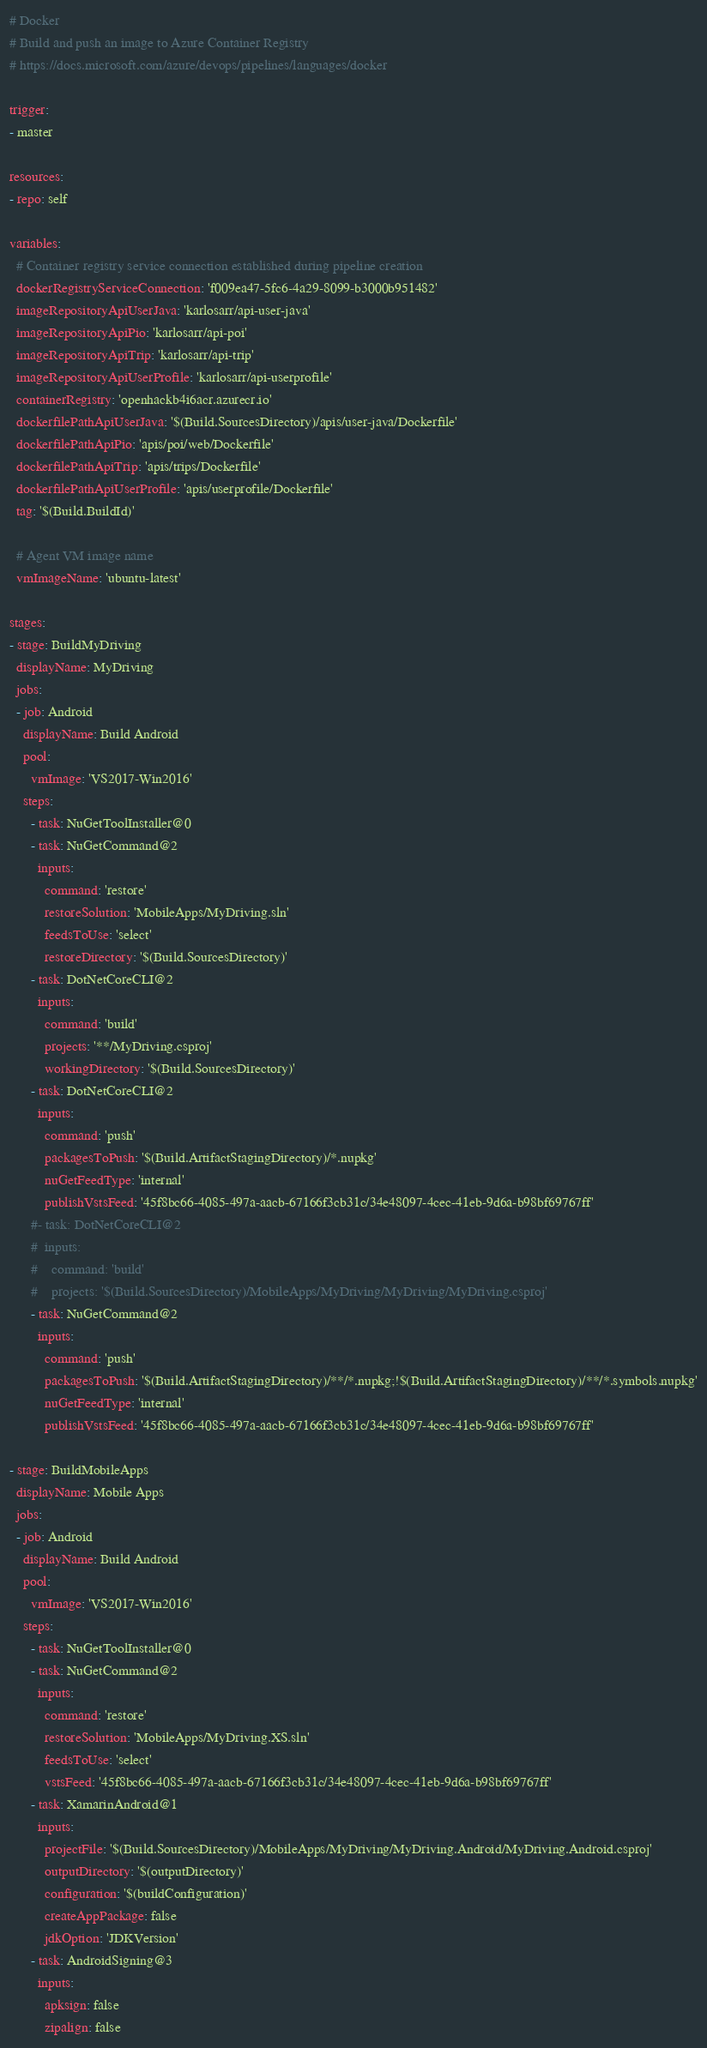Convert code to text. <code><loc_0><loc_0><loc_500><loc_500><_YAML_># Docker
# Build and push an image to Azure Container Registry
# https://docs.microsoft.com/azure/devops/pipelines/languages/docker

trigger:
- master

resources:
- repo: self

variables:
  # Container registry service connection established during pipeline creation
  dockerRegistryServiceConnection: 'f009ea47-5fc6-4a29-8099-b3000b951482'
  imageRepositoryApiUserJava: 'karlosarr/api-user-java'
  imageRepositoryApiPio: 'karlosarr/api-poi'
  imageRepositoryApiTrip: 'karlosarr/api-trip'
  imageRepositoryApiUserProfile: 'karlosarr/api-userprofile'
  containerRegistry: 'openhackb4i6acr.azurecr.io'
  dockerfilePathApiUserJava: '$(Build.SourcesDirectory)/apis/user-java/Dockerfile'
  dockerfilePathApiPio: 'apis/poi/web/Dockerfile'
  dockerfilePathApiTrip: 'apis/trips/Dockerfile'
  dockerfilePathApiUserProfile: 'apis/userprofile/Dockerfile'
  tag: '$(Build.BuildId)'
  
  # Agent VM image name
  vmImageName: 'ubuntu-latest'

stages:
- stage: BuildMyDriving
  displayName: MyDriving
  jobs:
  - job: Android
    displayName: Build Android
    pool:
      vmImage: 'VS2017-Win2016'
    steps:
      - task: NuGetToolInstaller@0
      - task: NuGetCommand@2
        inputs:
          command: 'restore'
          restoreSolution: 'MobileApps/MyDriving.sln'
          feedsToUse: 'select'
          restoreDirectory: '$(Build.SourcesDirectory)'
      - task: DotNetCoreCLI@2
        inputs:
          command: 'build'
          projects: '**/MyDriving.csproj'
          workingDirectory: '$(Build.SourcesDirectory)'
      - task: DotNetCoreCLI@2
        inputs:
          command: 'push'
          packagesToPush: '$(Build.ArtifactStagingDirectory)/*.nupkg'
          nuGetFeedType: 'internal'
          publishVstsFeed: '45f8bc66-4085-497a-aacb-67166f3cb31c/34e48097-4cec-41eb-9d6a-b98bf69767ff'
      #- task: DotNetCoreCLI@2
      #  inputs:
      #    command: 'build'
      #    projects: '$(Build.SourcesDirectory)/MobileApps/MyDriving/MyDriving/MyDriving.csproj'
      - task: NuGetCommand@2
        inputs:
          command: 'push'
          packagesToPush: '$(Build.ArtifactStagingDirectory)/**/*.nupkg;!$(Build.ArtifactStagingDirectory)/**/*.symbols.nupkg'
          nuGetFeedType: 'internal'
          publishVstsFeed: '45f8bc66-4085-497a-aacb-67166f3cb31c/34e48097-4cec-41eb-9d6a-b98bf69767ff'

- stage: BuildMobileApps
  displayName: Mobile Apps
  jobs:
  - job: Android
    displayName: Build Android
    pool:
      vmImage: 'VS2017-Win2016'
    steps:
      - task: NuGetToolInstaller@0
      - task: NuGetCommand@2
        inputs:
          command: 'restore'
          restoreSolution: 'MobileApps/MyDriving.XS.sln'
          feedsToUse: 'select'
          vstsFeed: '45f8bc66-4085-497a-aacb-67166f3cb31c/34e48097-4cec-41eb-9d6a-b98bf69767ff'
      - task: XamarinAndroid@1
        inputs:
          projectFile: '$(Build.SourcesDirectory)/MobileApps/MyDriving/MyDriving.Android/MyDriving.Android.csproj'
          outputDirectory: '$(outputDirectory)'
          configuration: '$(buildConfiguration)'
          createAppPackage: false
          jdkOption: 'JDKVersion'
      - task: AndroidSigning@3
        inputs:
          apksign: false
          zipalign: false</code> 